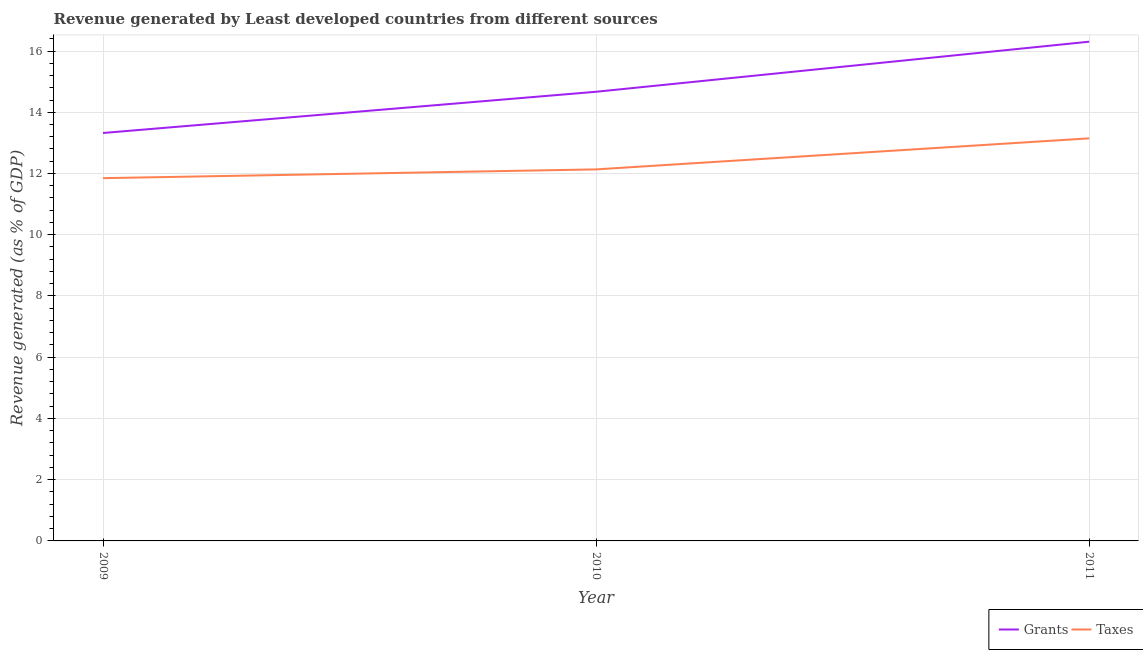Does the line corresponding to revenue generated by grants intersect with the line corresponding to revenue generated by taxes?
Give a very brief answer. No. What is the revenue generated by grants in 2011?
Make the answer very short. 16.3. Across all years, what is the maximum revenue generated by grants?
Offer a very short reply. 16.3. Across all years, what is the minimum revenue generated by grants?
Your answer should be compact. 13.32. In which year was the revenue generated by taxes minimum?
Give a very brief answer. 2009. What is the total revenue generated by taxes in the graph?
Ensure brevity in your answer.  37.13. What is the difference between the revenue generated by taxes in 2009 and that in 2010?
Provide a short and direct response. -0.29. What is the difference between the revenue generated by taxes in 2010 and the revenue generated by grants in 2011?
Provide a short and direct response. -4.17. What is the average revenue generated by taxes per year?
Give a very brief answer. 12.38. In the year 2010, what is the difference between the revenue generated by grants and revenue generated by taxes?
Provide a succinct answer. 2.54. What is the ratio of the revenue generated by grants in 2009 to that in 2010?
Ensure brevity in your answer.  0.91. Is the revenue generated by taxes in 2010 less than that in 2011?
Make the answer very short. Yes. Is the difference between the revenue generated by taxes in 2010 and 2011 greater than the difference between the revenue generated by grants in 2010 and 2011?
Your response must be concise. Yes. What is the difference between the highest and the second highest revenue generated by grants?
Provide a succinct answer. 1.64. What is the difference between the highest and the lowest revenue generated by grants?
Provide a succinct answer. 2.98. Is the sum of the revenue generated by taxes in 2010 and 2011 greater than the maximum revenue generated by grants across all years?
Offer a very short reply. Yes. Does the revenue generated by grants monotonically increase over the years?
Keep it short and to the point. Yes. Is the revenue generated by taxes strictly greater than the revenue generated by grants over the years?
Offer a very short reply. No. How many lines are there?
Your answer should be compact. 2. What is the difference between two consecutive major ticks on the Y-axis?
Keep it short and to the point. 2. Are the values on the major ticks of Y-axis written in scientific E-notation?
Your response must be concise. No. Does the graph contain grids?
Offer a terse response. Yes. What is the title of the graph?
Your answer should be very brief. Revenue generated by Least developed countries from different sources. Does "Exports of goods" appear as one of the legend labels in the graph?
Your answer should be compact. No. What is the label or title of the Y-axis?
Offer a very short reply. Revenue generated (as % of GDP). What is the Revenue generated (as % of GDP) of Grants in 2009?
Keep it short and to the point. 13.32. What is the Revenue generated (as % of GDP) in Taxes in 2009?
Provide a short and direct response. 11.85. What is the Revenue generated (as % of GDP) in Grants in 2010?
Your answer should be very brief. 14.67. What is the Revenue generated (as % of GDP) of Taxes in 2010?
Make the answer very short. 12.13. What is the Revenue generated (as % of GDP) of Grants in 2011?
Offer a very short reply. 16.3. What is the Revenue generated (as % of GDP) in Taxes in 2011?
Keep it short and to the point. 13.15. Across all years, what is the maximum Revenue generated (as % of GDP) of Grants?
Offer a very short reply. 16.3. Across all years, what is the maximum Revenue generated (as % of GDP) in Taxes?
Your answer should be very brief. 13.15. Across all years, what is the minimum Revenue generated (as % of GDP) of Grants?
Your answer should be compact. 13.32. Across all years, what is the minimum Revenue generated (as % of GDP) in Taxes?
Provide a succinct answer. 11.85. What is the total Revenue generated (as % of GDP) in Grants in the graph?
Provide a short and direct response. 44.3. What is the total Revenue generated (as % of GDP) in Taxes in the graph?
Your answer should be very brief. 37.13. What is the difference between the Revenue generated (as % of GDP) in Grants in 2009 and that in 2010?
Give a very brief answer. -1.35. What is the difference between the Revenue generated (as % of GDP) of Taxes in 2009 and that in 2010?
Your answer should be compact. -0.29. What is the difference between the Revenue generated (as % of GDP) of Grants in 2009 and that in 2011?
Your answer should be compact. -2.98. What is the difference between the Revenue generated (as % of GDP) in Taxes in 2009 and that in 2011?
Keep it short and to the point. -1.3. What is the difference between the Revenue generated (as % of GDP) of Grants in 2010 and that in 2011?
Provide a succinct answer. -1.64. What is the difference between the Revenue generated (as % of GDP) of Taxes in 2010 and that in 2011?
Provide a short and direct response. -1.01. What is the difference between the Revenue generated (as % of GDP) of Grants in 2009 and the Revenue generated (as % of GDP) of Taxes in 2010?
Your answer should be compact. 1.19. What is the difference between the Revenue generated (as % of GDP) in Grants in 2009 and the Revenue generated (as % of GDP) in Taxes in 2011?
Offer a terse response. 0.18. What is the difference between the Revenue generated (as % of GDP) of Grants in 2010 and the Revenue generated (as % of GDP) of Taxes in 2011?
Offer a very short reply. 1.52. What is the average Revenue generated (as % of GDP) in Grants per year?
Make the answer very short. 14.77. What is the average Revenue generated (as % of GDP) in Taxes per year?
Provide a succinct answer. 12.38. In the year 2009, what is the difference between the Revenue generated (as % of GDP) in Grants and Revenue generated (as % of GDP) in Taxes?
Ensure brevity in your answer.  1.48. In the year 2010, what is the difference between the Revenue generated (as % of GDP) of Grants and Revenue generated (as % of GDP) of Taxes?
Give a very brief answer. 2.54. In the year 2011, what is the difference between the Revenue generated (as % of GDP) in Grants and Revenue generated (as % of GDP) in Taxes?
Your answer should be compact. 3.16. What is the ratio of the Revenue generated (as % of GDP) of Grants in 2009 to that in 2010?
Keep it short and to the point. 0.91. What is the ratio of the Revenue generated (as % of GDP) in Taxes in 2009 to that in 2010?
Make the answer very short. 0.98. What is the ratio of the Revenue generated (as % of GDP) of Grants in 2009 to that in 2011?
Your response must be concise. 0.82. What is the ratio of the Revenue generated (as % of GDP) in Taxes in 2009 to that in 2011?
Provide a succinct answer. 0.9. What is the ratio of the Revenue generated (as % of GDP) of Grants in 2010 to that in 2011?
Provide a short and direct response. 0.9. What is the ratio of the Revenue generated (as % of GDP) in Taxes in 2010 to that in 2011?
Provide a short and direct response. 0.92. What is the difference between the highest and the second highest Revenue generated (as % of GDP) of Grants?
Provide a succinct answer. 1.64. What is the difference between the highest and the second highest Revenue generated (as % of GDP) of Taxes?
Keep it short and to the point. 1.01. What is the difference between the highest and the lowest Revenue generated (as % of GDP) in Grants?
Your response must be concise. 2.98. What is the difference between the highest and the lowest Revenue generated (as % of GDP) in Taxes?
Your response must be concise. 1.3. 